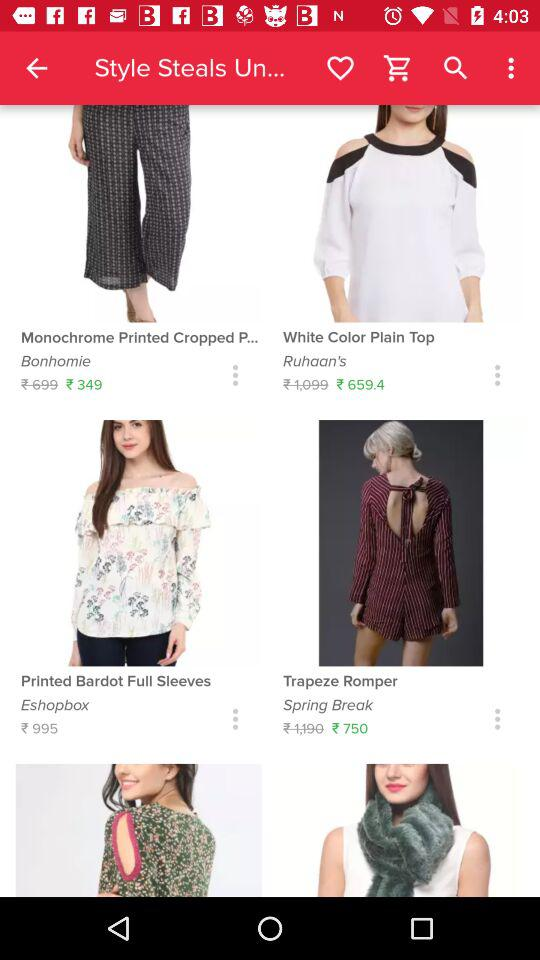What is the price of "Printed Bardot Full Sleeves"? The price of "Printed Bardot Full Sleeves" is ₹995. 